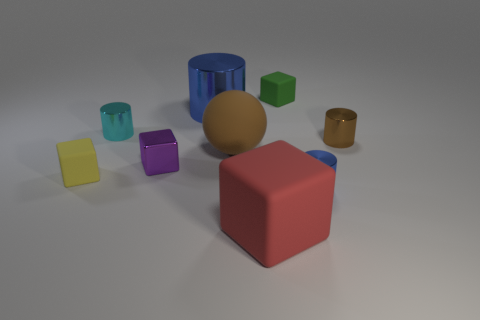Subtract all tiny green cubes. How many cubes are left? 3 Subtract all yellow cubes. How many blue cylinders are left? 2 Subtract all green blocks. How many blocks are left? 3 Subtract 1 cubes. How many cubes are left? 3 Add 1 tiny cyan things. How many objects exist? 10 Subtract all blue blocks. Subtract all blue cylinders. How many blocks are left? 4 Subtract 2 blue cylinders. How many objects are left? 7 Subtract all spheres. How many objects are left? 8 Subtract all small metallic objects. Subtract all large blue cylinders. How many objects are left? 4 Add 3 small yellow things. How many small yellow things are left? 4 